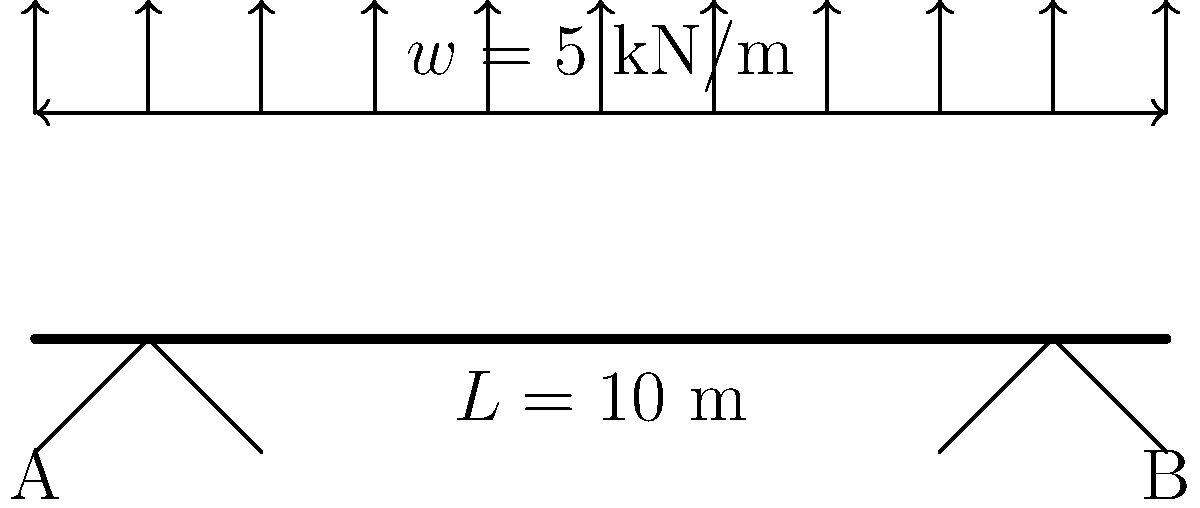Consider a simply supported beam of length $L = 10$ m with a uniformly distributed load of $w = 5$ kN/m along its entire length. Calculate the maximum bending moment in the beam. To find the maximum bending moment, we'll follow these steps:

1) First, calculate the total load on the beam:
   $W = w \times L = 5 \text{ kN/m} \times 10 \text{ m} = 50 \text{ kN}$

2) For a simply supported beam with uniform load, each support reaction is half of the total load:
   $R_A = R_B = \frac{W}{2} = \frac{50 \text{ kN}}{2} = 25 \text{ kN}$

3) The maximum bending moment occurs at the middle of the beam. We can calculate it using the formula:
   $M_{max} = \frac{wL^2}{8}$

4) Substituting the values:
   $M_{max} = \frac{5 \text{ kN/m} \times (10 \text{ m})^2}{8} = \frac{500 \text{ kN}\cdot\text{m}}{8} = 62.5 \text{ kN}\cdot\text{m}$

Therefore, the maximum bending moment in the beam is 62.5 kN·m.
Answer: 62.5 kN·m 